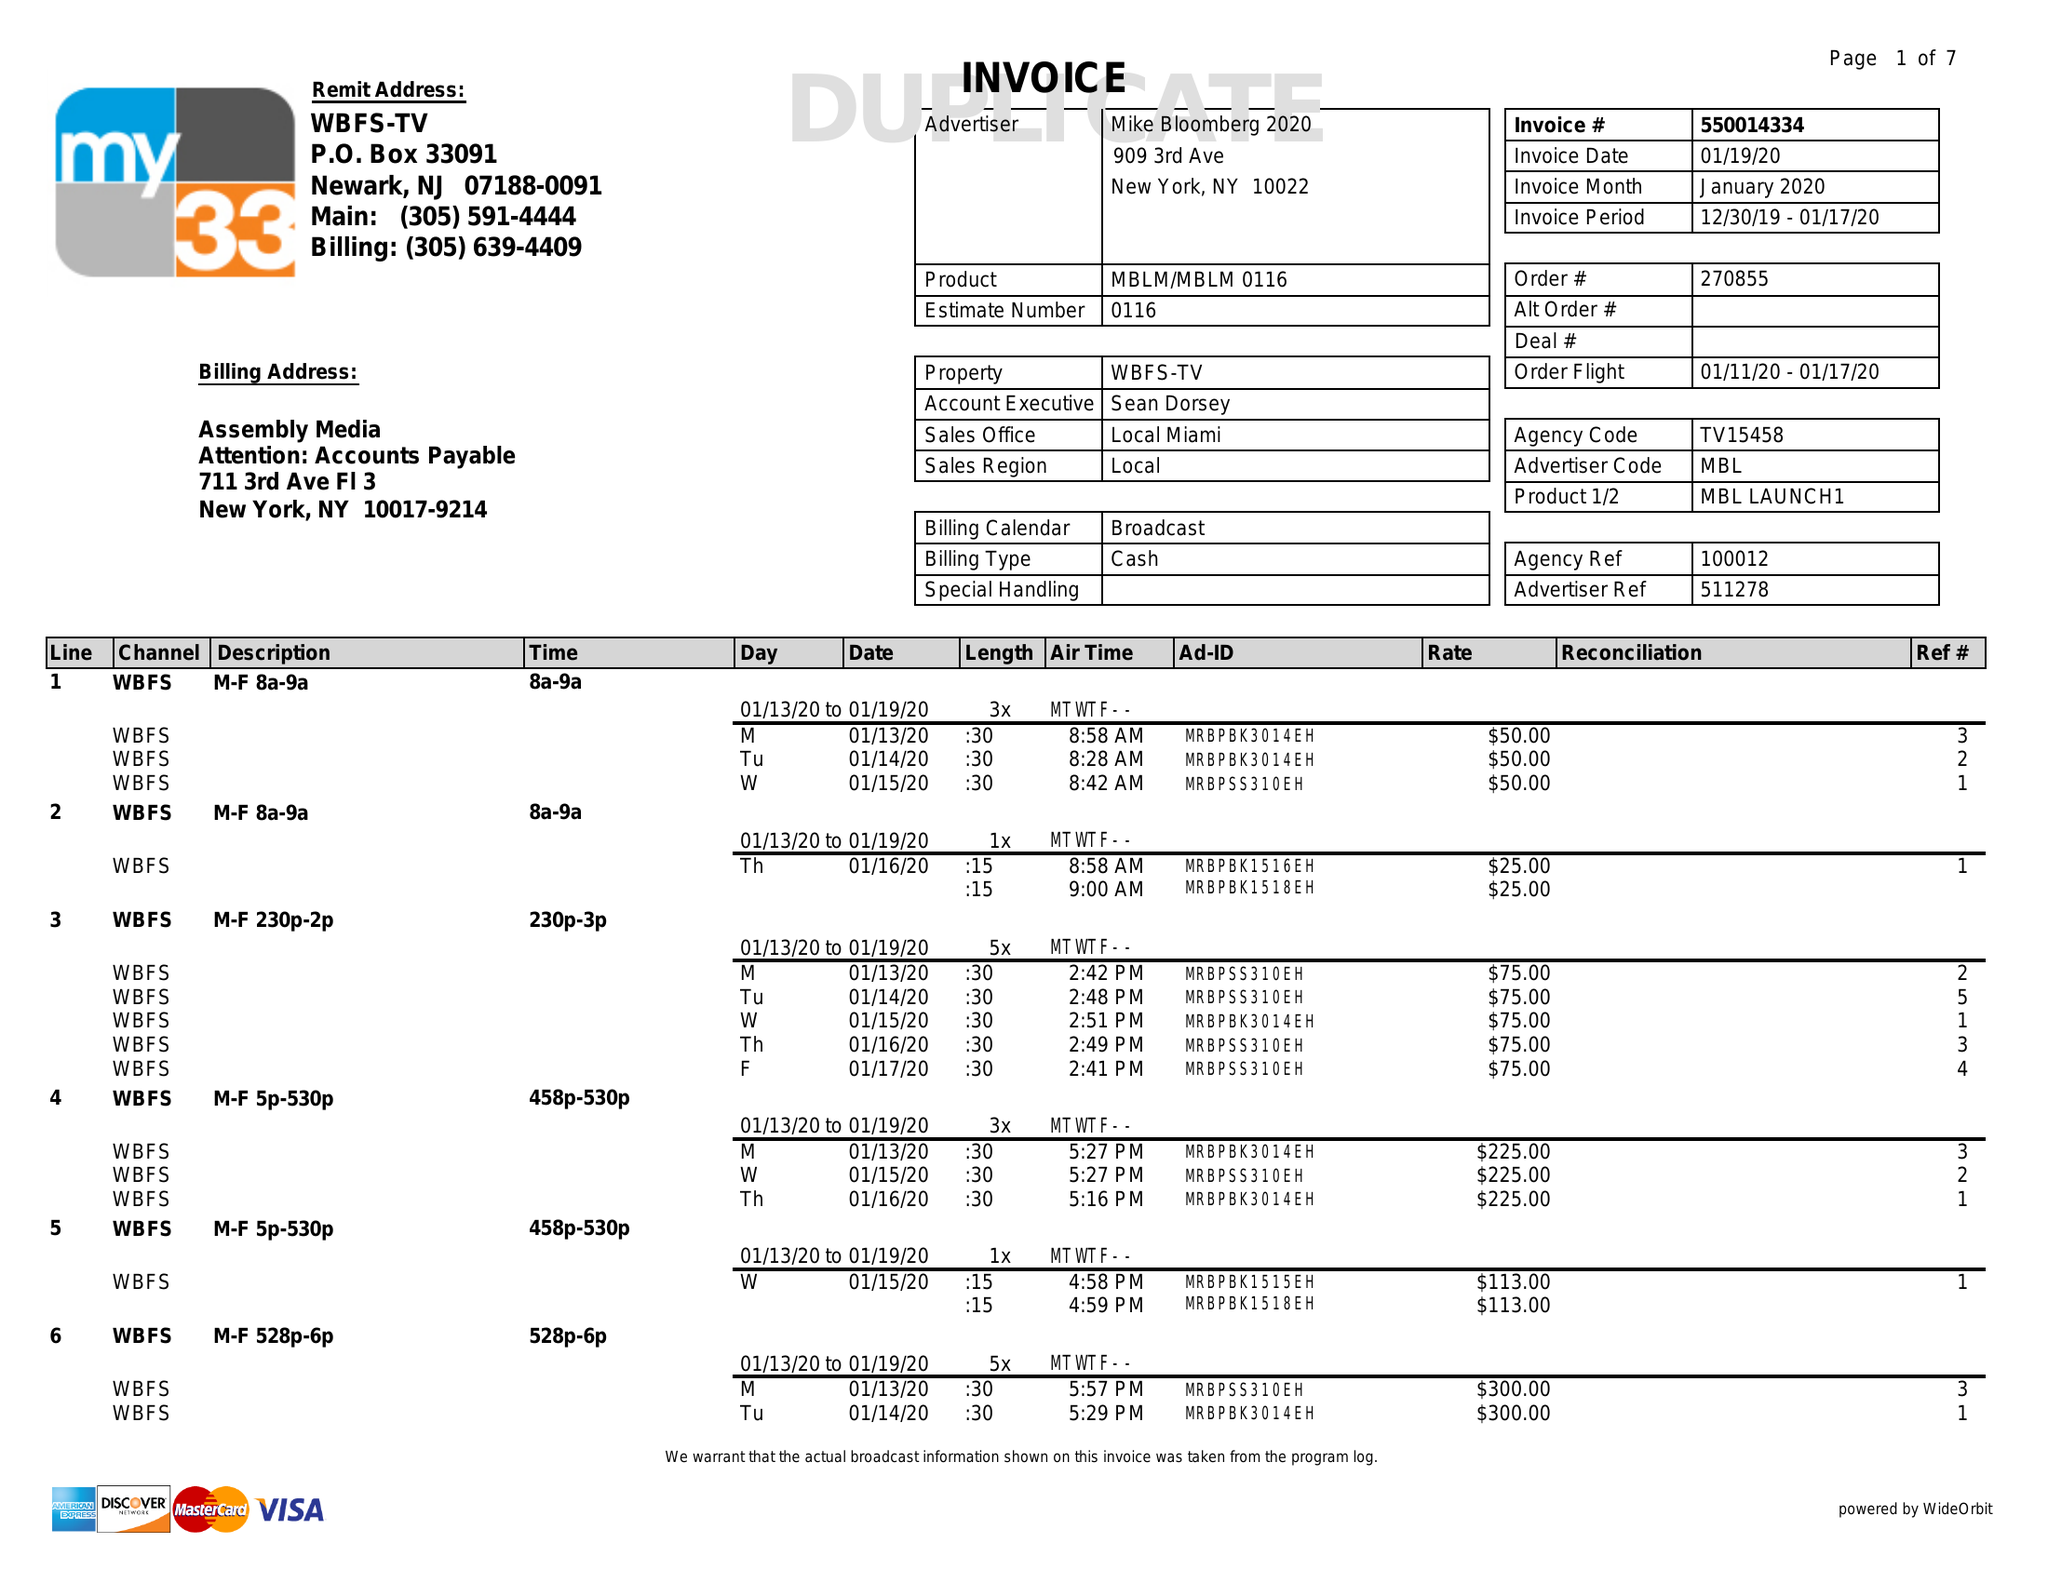What is the value for the flight_to?
Answer the question using a single word or phrase. 01/17/20 